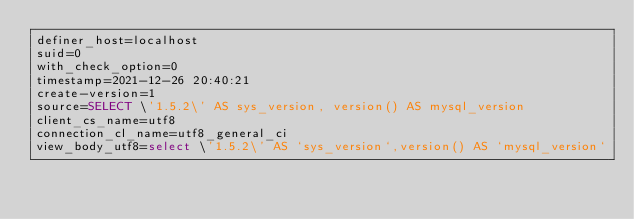Convert code to text. <code><loc_0><loc_0><loc_500><loc_500><_VisualBasic_>definer_host=localhost
suid=0
with_check_option=0
timestamp=2021-12-26 20:40:21
create-version=1
source=SELECT \'1.5.2\' AS sys_version, version() AS mysql_version
client_cs_name=utf8
connection_cl_name=utf8_general_ci
view_body_utf8=select \'1.5.2\' AS `sys_version`,version() AS `mysql_version`
</code> 